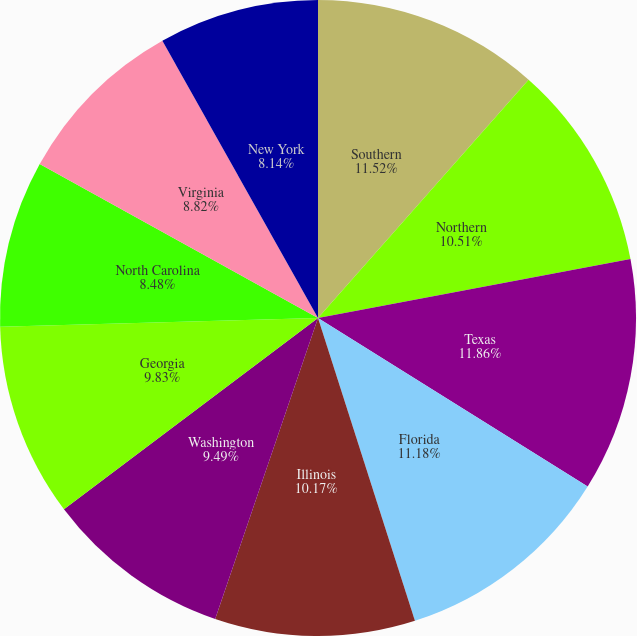Convert chart. <chart><loc_0><loc_0><loc_500><loc_500><pie_chart><fcel>Southern<fcel>Northern<fcel>Texas<fcel>Florida<fcel>Illinois<fcel>Washington<fcel>Georgia<fcel>North Carolina<fcel>Virginia<fcel>New York<nl><fcel>11.52%<fcel>10.51%<fcel>11.86%<fcel>11.18%<fcel>10.17%<fcel>9.49%<fcel>9.83%<fcel>8.48%<fcel>8.82%<fcel>8.14%<nl></chart> 